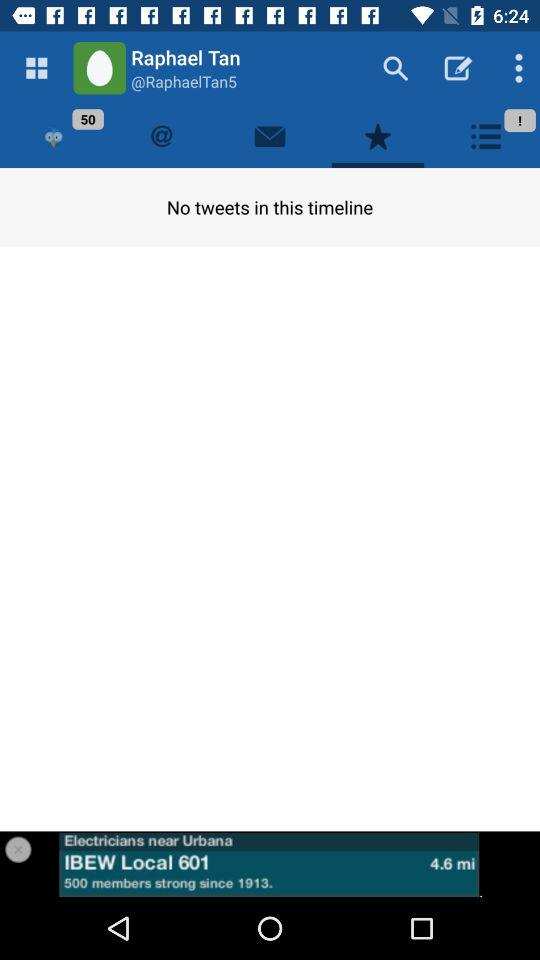How many tweets are here in the timeline? In the timeline, there is no tweet. 